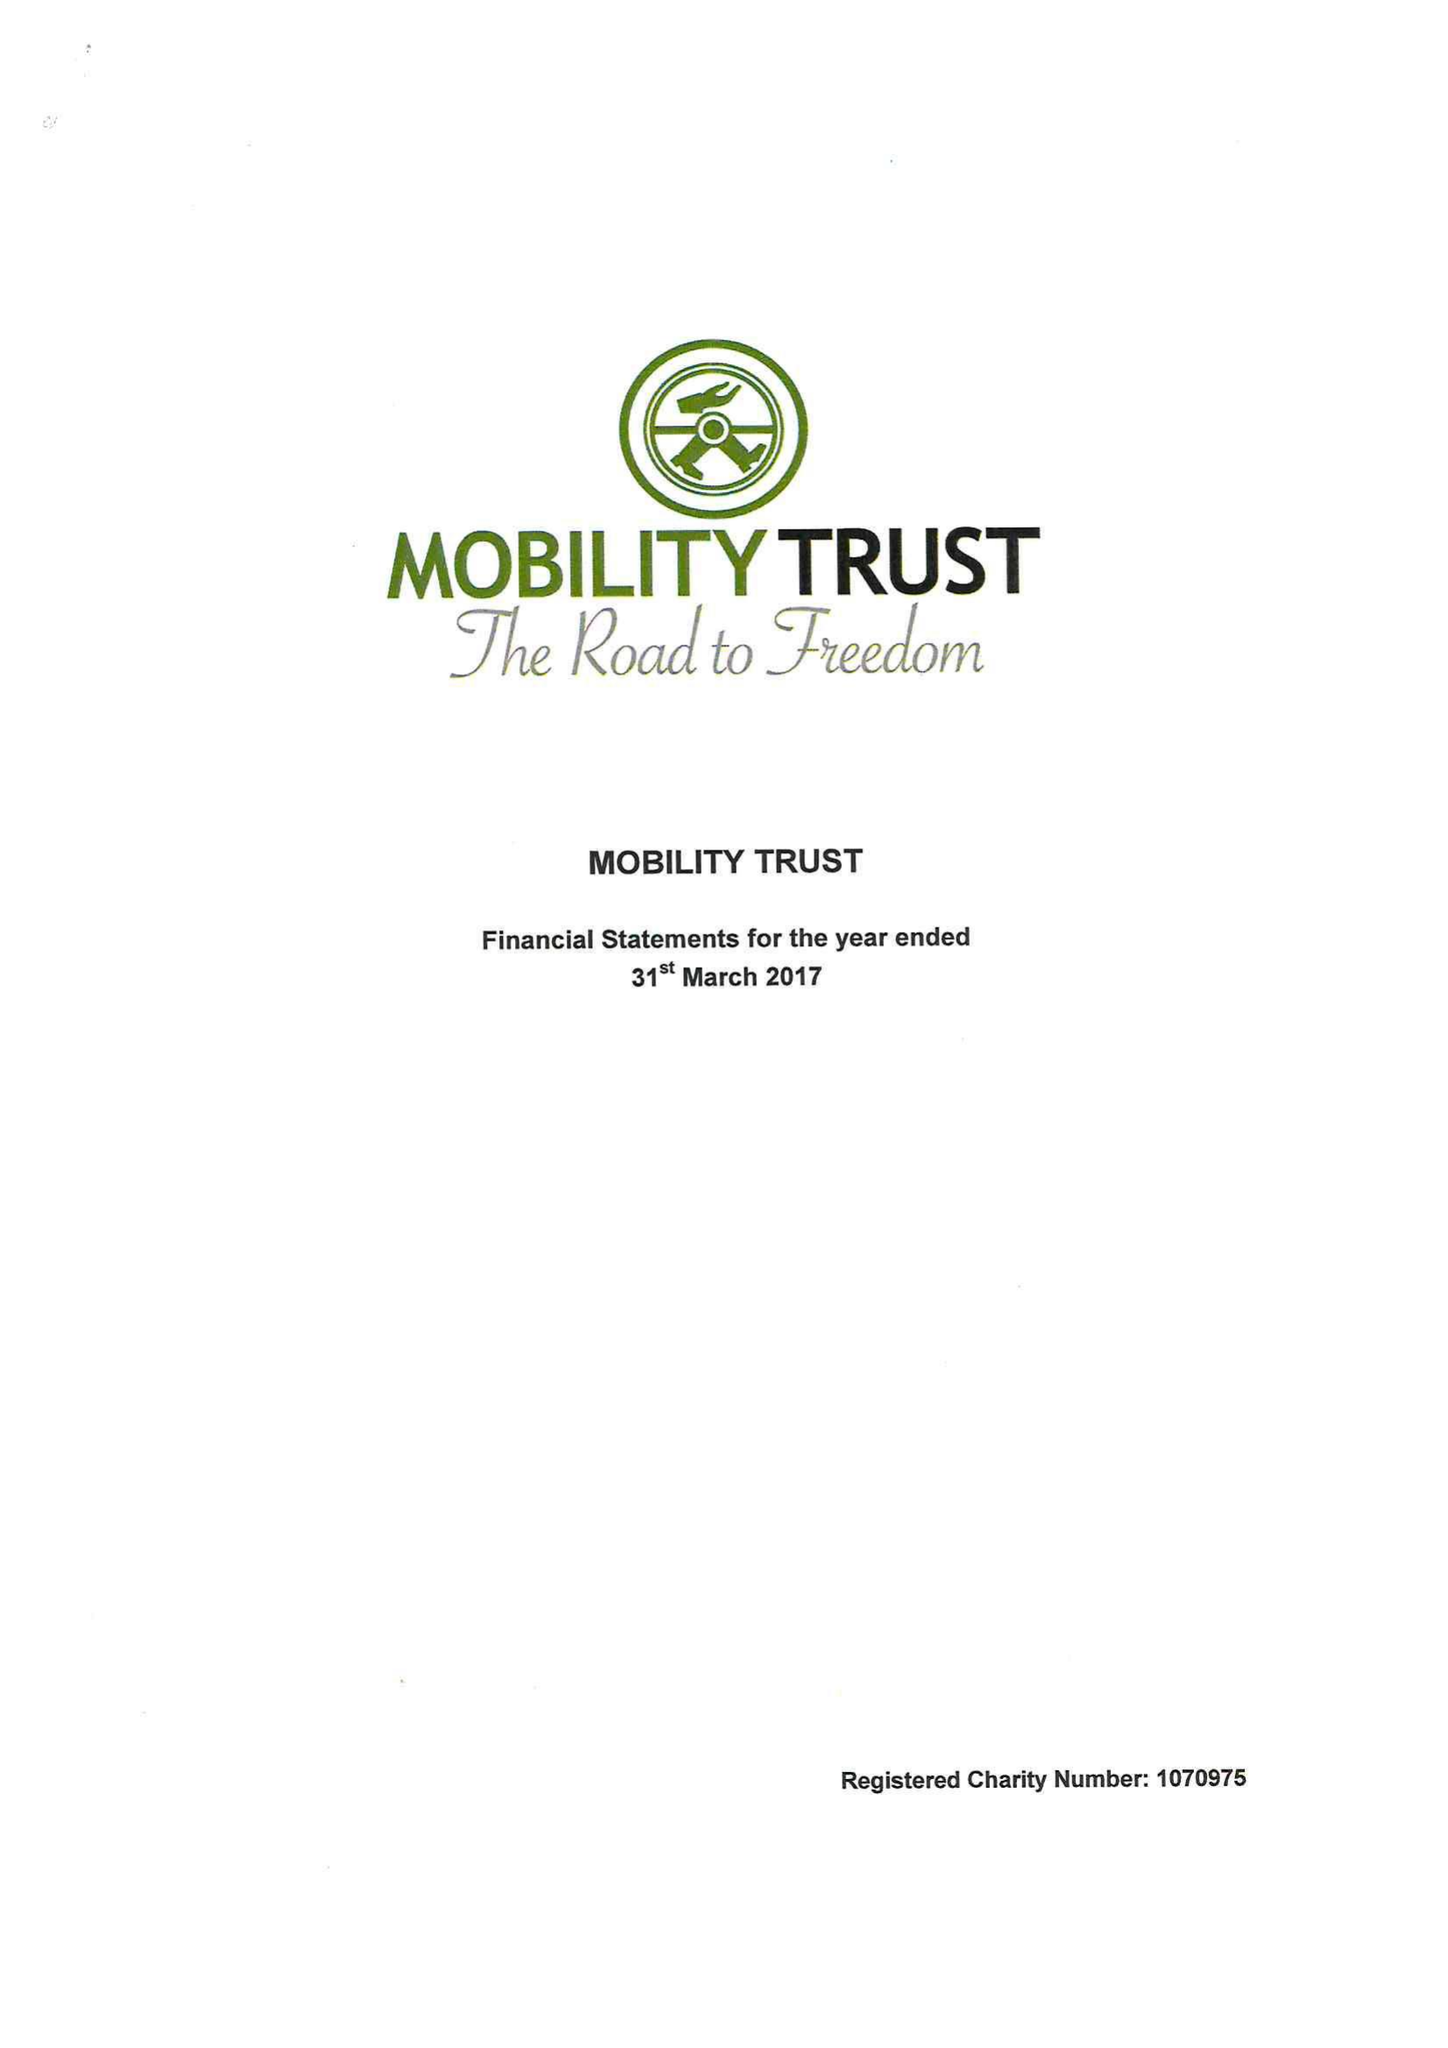What is the value for the charity_number?
Answer the question using a single word or phrase. 1070975 